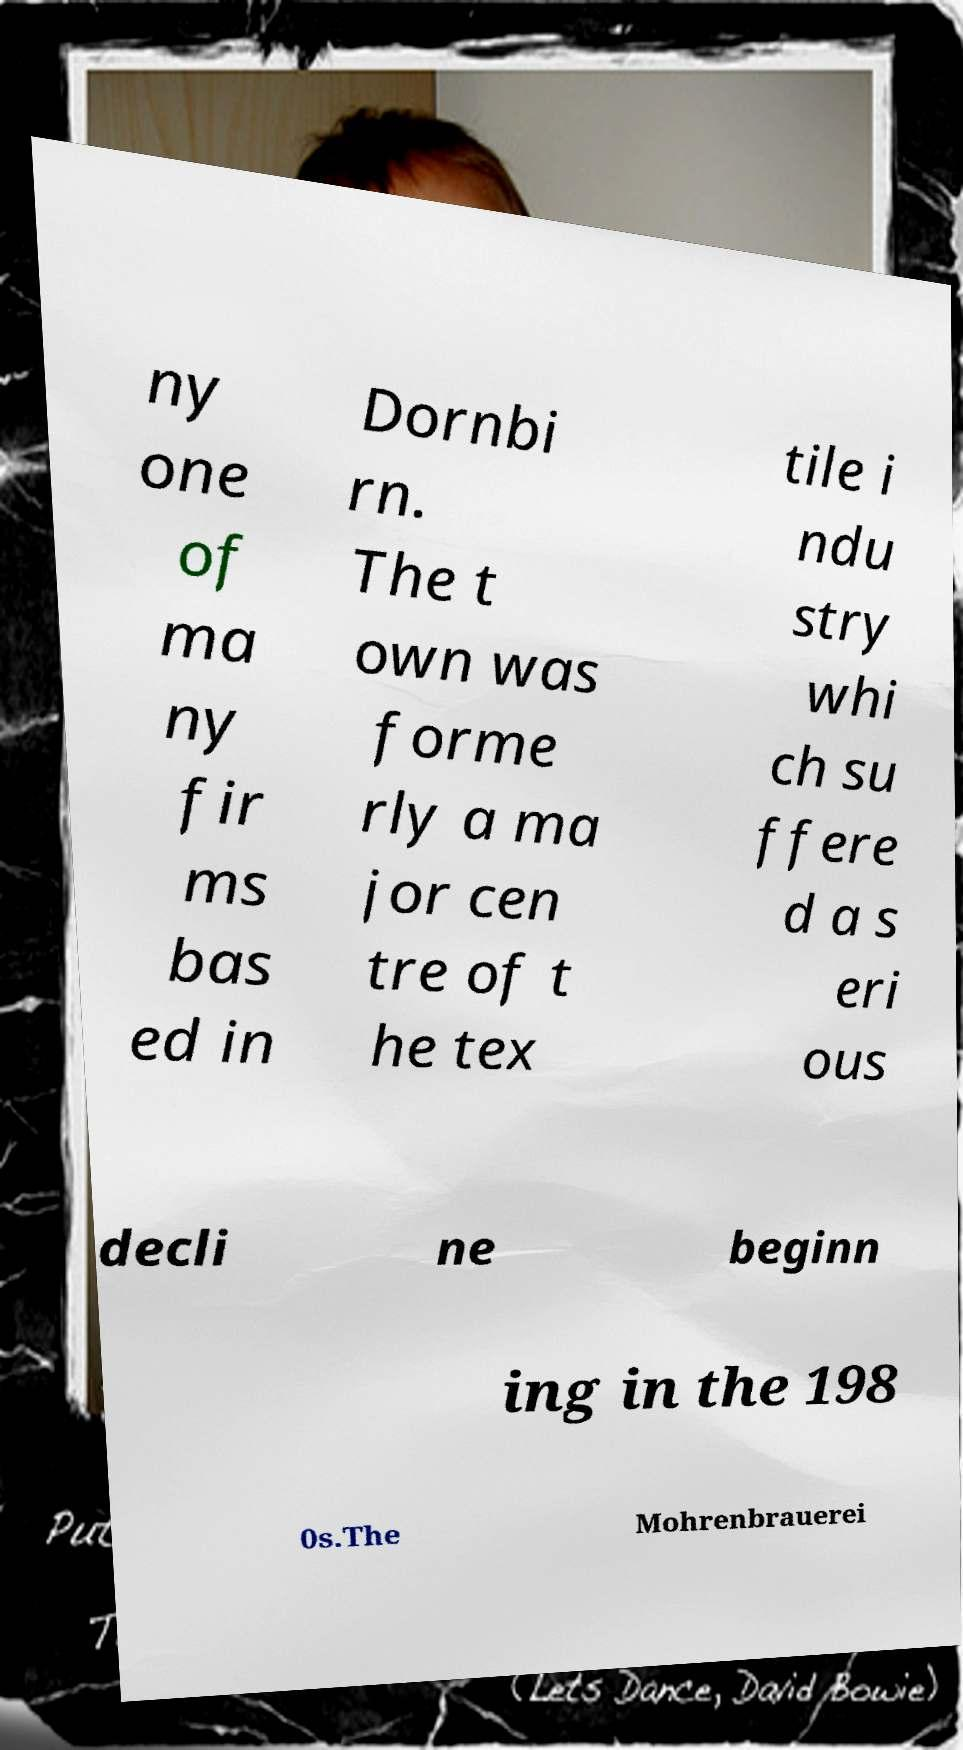There's text embedded in this image that I need extracted. Can you transcribe it verbatim? ny one of ma ny fir ms bas ed in Dornbi rn. The t own was forme rly a ma jor cen tre of t he tex tile i ndu stry whi ch su ffere d a s eri ous decli ne beginn ing in the 198 0s.The Mohrenbrauerei 